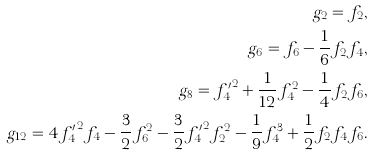Convert formula to latex. <formula><loc_0><loc_0><loc_500><loc_500>g _ { 2 } = f _ { 2 } , \\ g _ { 6 } = f _ { 6 } - \frac { 1 } { 6 } f _ { 2 } f _ { 4 } , \\ g _ { 8 } = { f ^ { \prime } _ { 4 } } ^ { 2 } + \frac { 1 } { 1 2 } f _ { 4 } ^ { 2 } - \frac { 1 } { 4 } f _ { 2 } f _ { 6 } , \\ g _ { 1 2 } = 4 { f ^ { \prime } _ { 4 } } ^ { 2 } f _ { 4 } - \frac { 3 } { 2 } f _ { 6 } ^ { 2 } - \frac { 3 } { 2 } { f ^ { \prime } _ { 4 } } ^ { 2 } f _ { 2 } ^ { 2 } - \frac { 1 } { 9 } f _ { 4 } ^ { 3 } + \frac { 1 } { 2 } f _ { 2 } f _ { 4 } f _ { 6 } .</formula> 